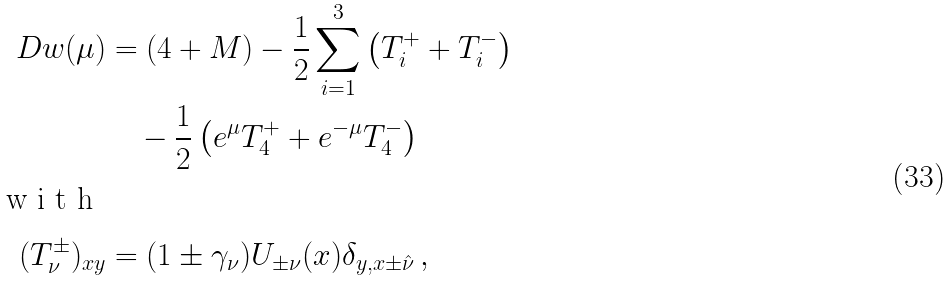Convert formula to latex. <formula><loc_0><loc_0><loc_500><loc_500>\ D w ( \mu ) & = ( 4 + M ) - \frac { 1 } { 2 } \sum _ { i = 1 } ^ { 3 } \left ( T _ { i } ^ { + } + T _ { i } ^ { - } \right ) \\ & \quad - \frac { 1 } { 2 } \left ( e ^ { \mu } T _ { 4 } ^ { + } + e ^ { - \mu } T _ { 4 } ^ { - } \right ) \intertext { w i t h } ( T _ { \nu } ^ { \pm } ) _ { x y } & = ( 1 \pm \gamma _ { \nu } ) U _ { \pm \nu } ( x ) \delta _ { y , x \pm \hat { \nu } } \, ,</formula> 